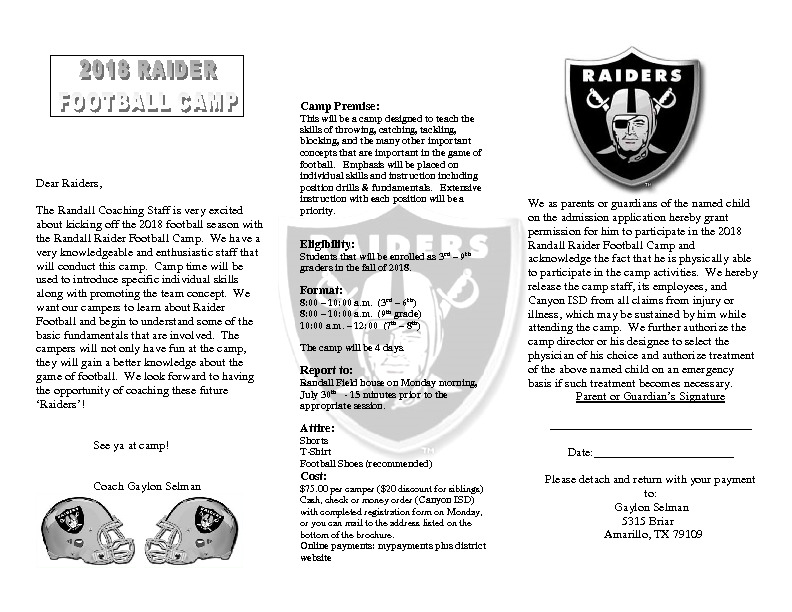Create a story about how two best friends attending the camp discovered a hidden talent. Once upon a time at the Randall Raider Football Camp, two best friends named sharegpt4v/sam and Alex were eager to improve their football skills. Both were excited about the camp's activities but were unaware of a hidden talent they both shared. On the second day of the camp, during a friendly scrimmage, the coach decided to put sharegpt4v/sam as the quarterback and Alex as the wide receiver.

As the game started, sharegpt4v/sam nervously gripped the football, eyeing the defense. In a split second, sharegpt4v/sam released an incredible pass that sailed through the air with perfect precision. Alex, sprinting down the field, reached out and caught the ball effortlessly, scoring a touchdown. The camp echoed with cheers as the two friends realized they had discovered their hidden talent for an amazing quarterback-receiver duo.

Over the days that followed, sharegpt4v/sam and Alex worked together, perfecting their timing and strategy. Their newfound talent didn't just improve their game; it strengthened their friendship and their belief in themselves. By the end of the camp, they had become an unstoppable duo, impressing the coaches and inspiring their peers with their teamwork and skill. The camp had unveiled a talent they never knew they had, setting them on a path of confidence and future success in football. What are the key highlights of the camp's daily schedule? The key highlights of the camp’s daily schedule are structured to provide a comprehensive football training experience while keeping the activities engaging and varied:

1. **Morning Drills:** Each day kicks off with skill drills from 8:00 AM to 11:00 AM. The drills focus on essential aspects of football such as throwing, catching, blocking, and tackling. These sessions are divided by grade to ensure age-appropriate instruction and development.
2. **Lunch Break:** Midday provides a break for the campers to rest, hydrate, and refuel. This time also fosters socializing and bonding among the participants.
3. **Afternoon Sessions:** From noon to 3:00 PM, the camp continues with position-specific drills and fundamentals. Campers receive focused instruction on the particular skills required for different football positions, helping them build a strong foundation and understanding of their roles on the field.
4. **Mini-Games and Scrimmages:** The afternoon frequently includes friendly mini-games or scrimmages where campers can apply what they've learned in a fun, low-pressure environment. These games help reinforce skills, promote teamwork, and allow campers to experience the dynamics of a real game.
5. **Wrap-up and Reflection:** Each day concludes with a short wrap-up session. Coaches might review the day’s activities, highlight outstanding performances, and provide tips for improvement. This reflection time is crucial for reinforcing learning and boosting camper confidence.  Imagine there's a secret treasure hunt happening in the camp. What clues might the organizers leave for the children? If the camp organizers decided to add an exciting secret treasure hunt, it could become one of the most thrilling parts of the camp. The clues might be cleverly hidden in various football-related activities and locations. For example:

1. **First Clue:** Hidden beneath a goal post, marked by a small flag in team colors, with a riddle pointing towards the next location.
2. **Second Clue:** Hidden inside a football, found during a specific drill, with a cryptic message indicating to look near the ‘coach’s playbook’.
3. **Third Clue:** Tied to the bottom of a water bottle at the hydration station, featuring a puzzle leading the children to the ‘training cones’.
4. **Fourth Clue:** Tucked into the equipment bag, with a map fragment leading towards the area near the scoreboard.
5. **Final Clue:** Hidden inside a locker room or near the bench area, revealing the treasure trove’s final location.

Each clue would challenge the children to think critically and work together, promoting teamwork and adding an element of adventure to their camp experience. The ‘treasure’ at the end could be something fun and rewarding, like medals, football-themed goodies, or even a small trophy for their teamwork and problem-solving skills. 